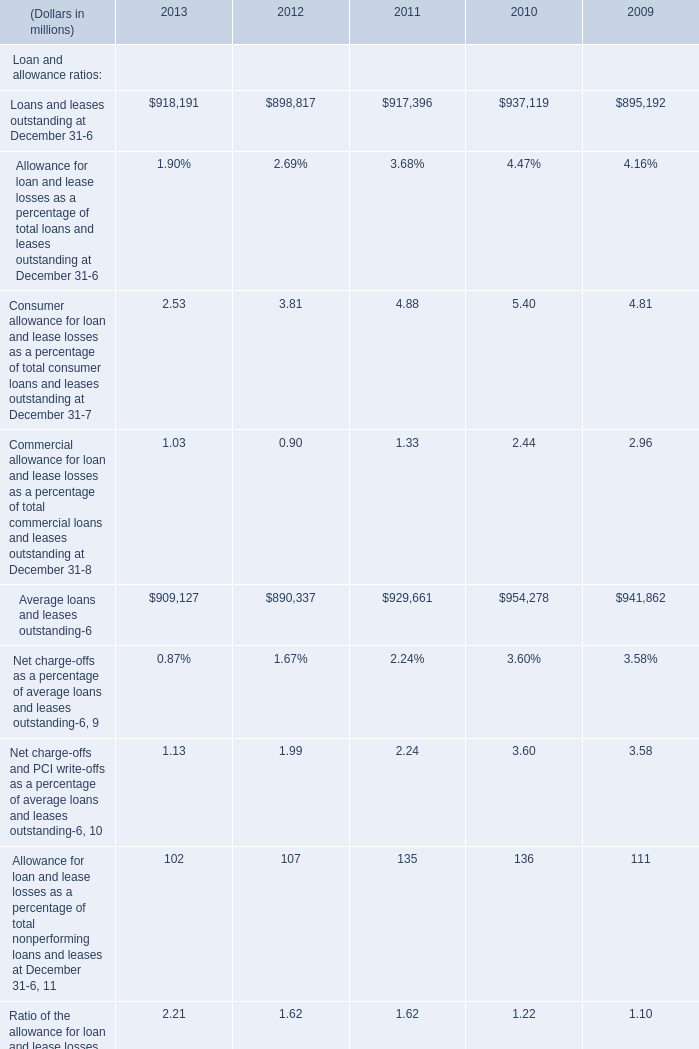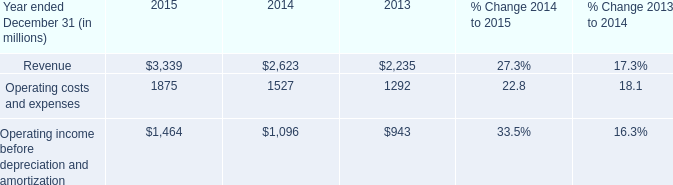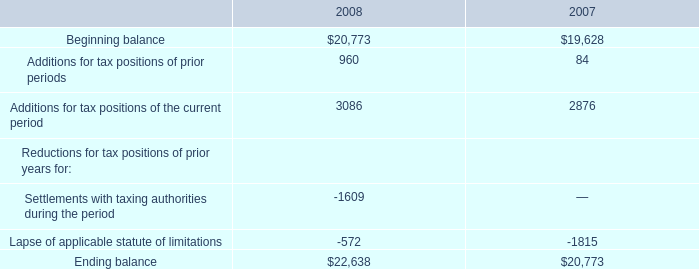What's the average of the loans and leases outstanding in the years where is Loans and leases outstanding positive? (in million) 
Computations: (((((909127 + 890337) + 929661) + 954278) + 941862) / 5)
Answer: 925053.0. 